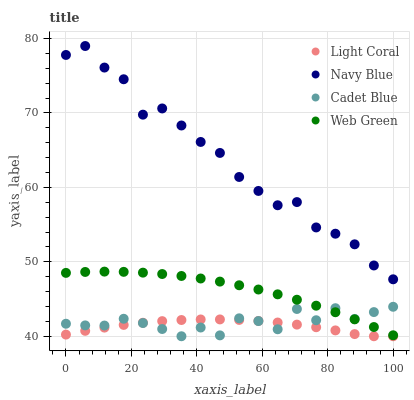Does Light Coral have the minimum area under the curve?
Answer yes or no. Yes. Does Navy Blue have the maximum area under the curve?
Answer yes or no. Yes. Does Cadet Blue have the minimum area under the curve?
Answer yes or no. No. Does Cadet Blue have the maximum area under the curve?
Answer yes or no. No. Is Web Green the smoothest?
Answer yes or no. Yes. Is Navy Blue the roughest?
Answer yes or no. Yes. Is Cadet Blue the smoothest?
Answer yes or no. No. Is Cadet Blue the roughest?
Answer yes or no. No. Does Light Coral have the lowest value?
Answer yes or no. Yes. Does Navy Blue have the lowest value?
Answer yes or no. No. Does Navy Blue have the highest value?
Answer yes or no. Yes. Does Cadet Blue have the highest value?
Answer yes or no. No. Is Cadet Blue less than Navy Blue?
Answer yes or no. Yes. Is Web Green greater than Light Coral?
Answer yes or no. Yes. Does Web Green intersect Cadet Blue?
Answer yes or no. Yes. Is Web Green less than Cadet Blue?
Answer yes or no. No. Is Web Green greater than Cadet Blue?
Answer yes or no. No. Does Cadet Blue intersect Navy Blue?
Answer yes or no. No. 